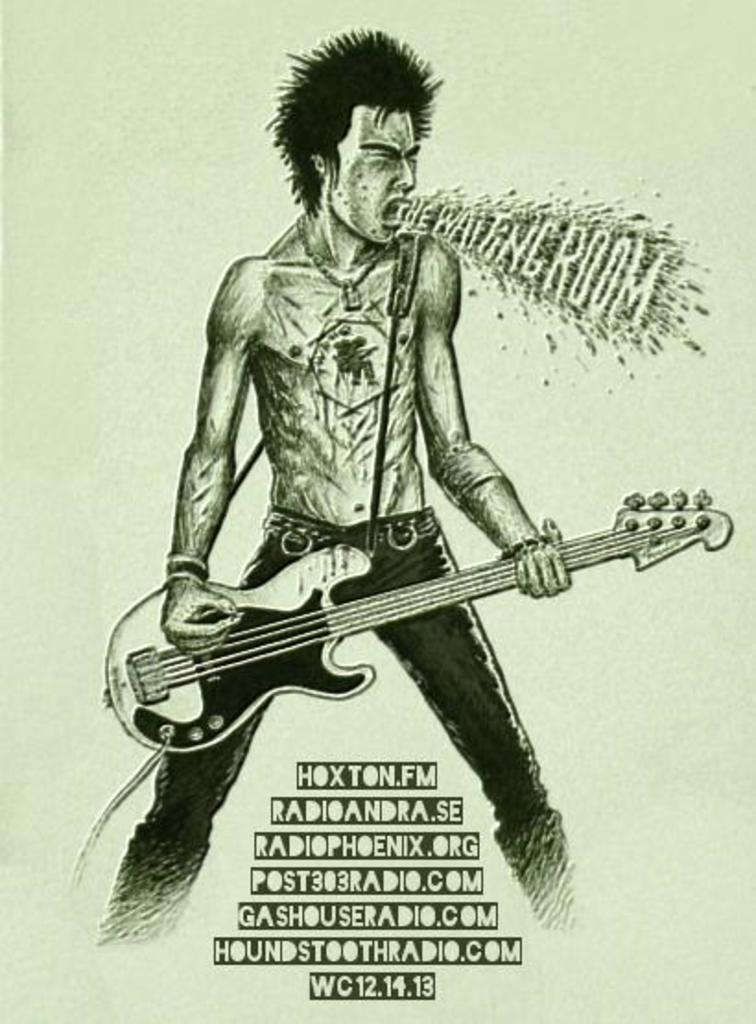What is the main subject of the image? There is a depiction of a man in the image. What is the man holding in the image? The man is holding a guitar. Where can text be found in the image? There is text on the right side and the bottom side of the image. What type of creature is crawling on the man's knee in the image? There is no creature crawling on the man's knee in the image. What material is the silk shirt made of that the man is wearing in the image? There is no mention of a shirt, let alone a silk shirt, in the image. 